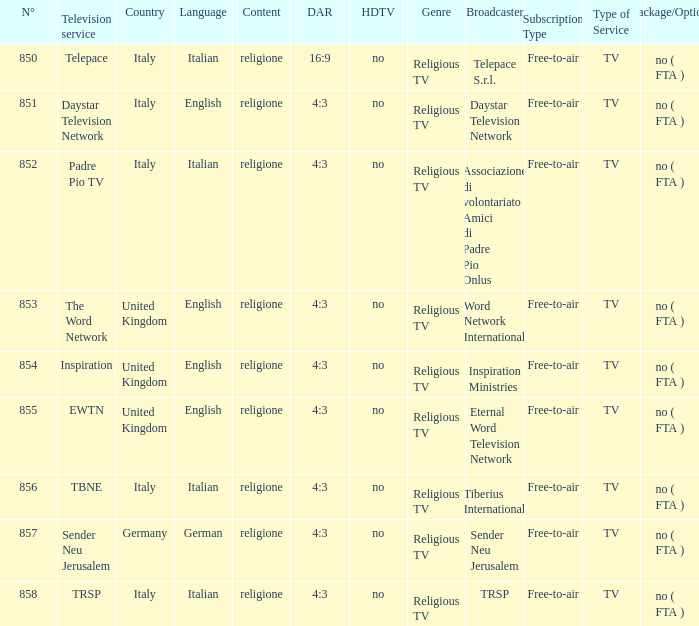How many television service are in italian and n°is greater than 856.0? TRSP. 